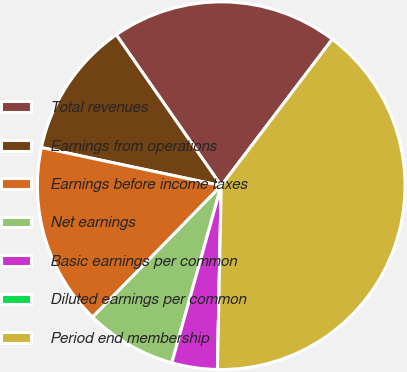Convert chart. <chart><loc_0><loc_0><loc_500><loc_500><pie_chart><fcel>Total revenues<fcel>Earnings from operations<fcel>Earnings before income taxes<fcel>Net earnings<fcel>Basic earnings per common<fcel>Diluted earnings per common<fcel>Period end membership<nl><fcel>20.0%<fcel>12.0%<fcel>16.0%<fcel>8.0%<fcel>4.0%<fcel>0.0%<fcel>40.0%<nl></chart> 